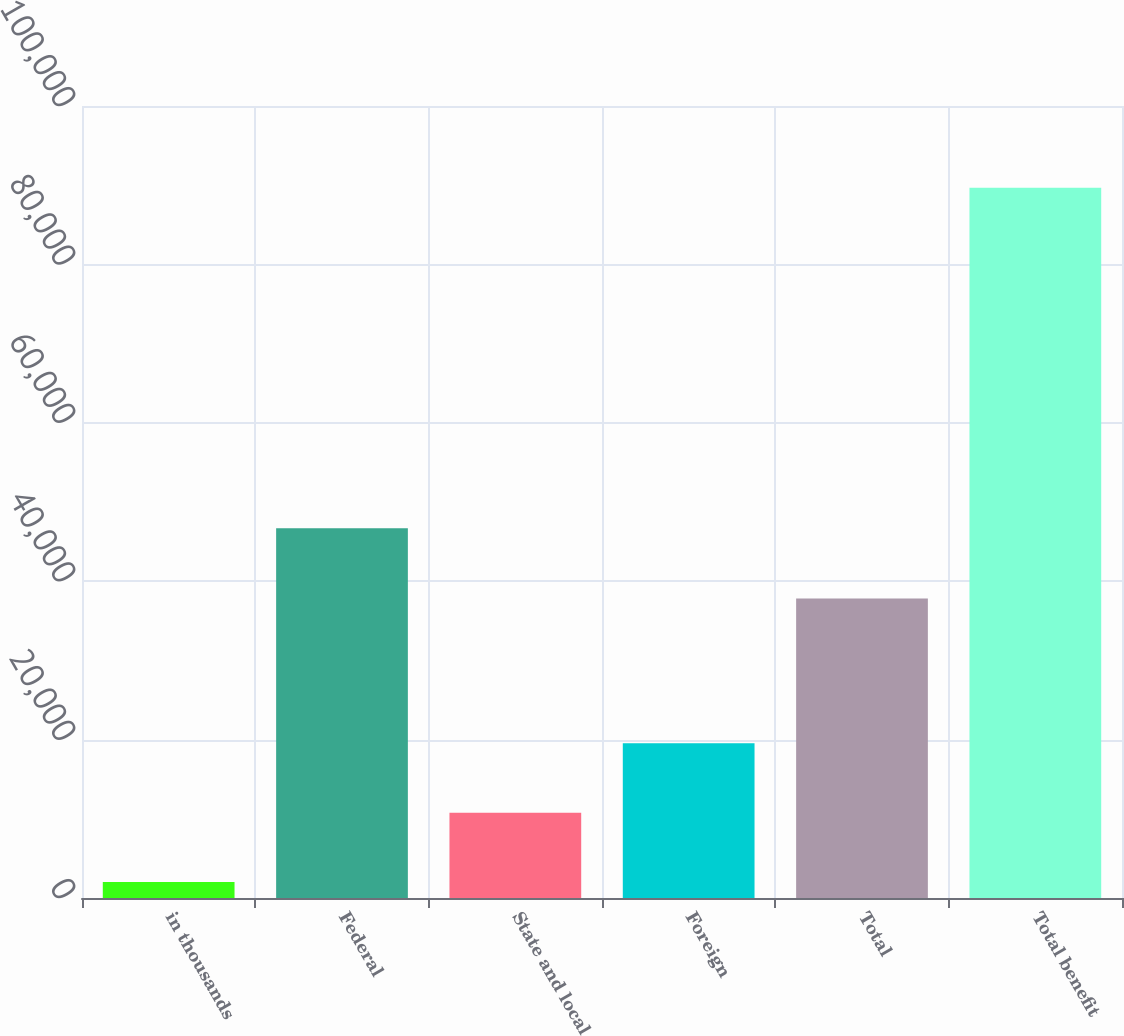Convert chart to OTSL. <chart><loc_0><loc_0><loc_500><loc_500><bar_chart><fcel>in thousands<fcel>Federal<fcel>State and local<fcel>Foreign<fcel>Total<fcel>Total benefit<nl><fcel>2010<fcel>46671<fcel>10775.3<fcel>19540.6<fcel>37805<fcel>89663<nl></chart> 